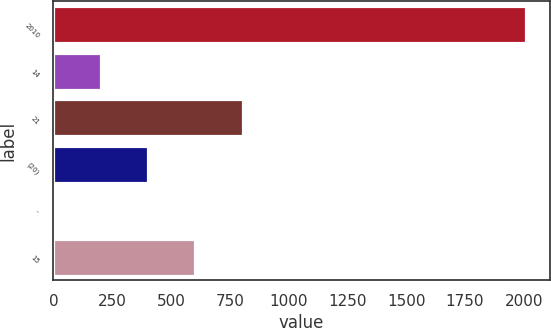Convert chart. <chart><loc_0><loc_0><loc_500><loc_500><bar_chart><fcel>2010<fcel>14<fcel>21<fcel>(20)<fcel>-<fcel>15<nl><fcel>2009<fcel>201.8<fcel>804.2<fcel>402.6<fcel>1<fcel>603.4<nl></chart> 